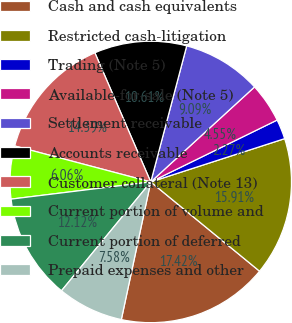Convert chart to OTSL. <chart><loc_0><loc_0><loc_500><loc_500><pie_chart><fcel>Cash and cash equivalents<fcel>Restricted cash-litigation<fcel>Trading (Note 5)<fcel>Available-for-sale (Note 5)<fcel>Settlement receivable<fcel>Accounts receivable<fcel>Customer collateral (Note 13)<fcel>Current portion of volume and<fcel>Current portion of deferred<fcel>Prepaid expenses and other<nl><fcel>17.42%<fcel>15.91%<fcel>2.27%<fcel>4.55%<fcel>9.09%<fcel>10.61%<fcel>14.39%<fcel>6.06%<fcel>12.12%<fcel>7.58%<nl></chart> 